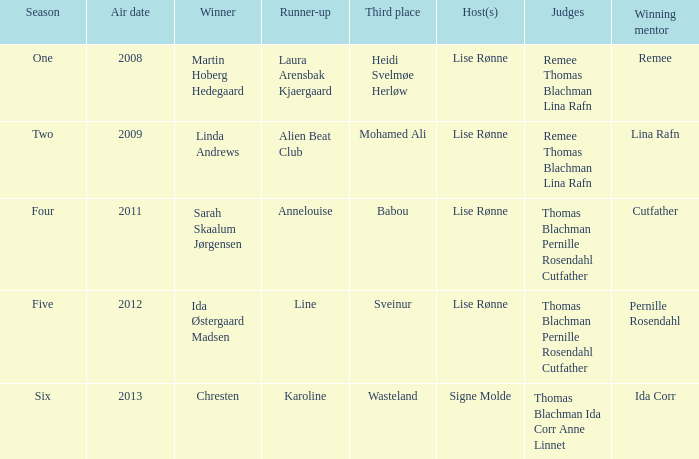In what season did ida corr claim her win? Six. 